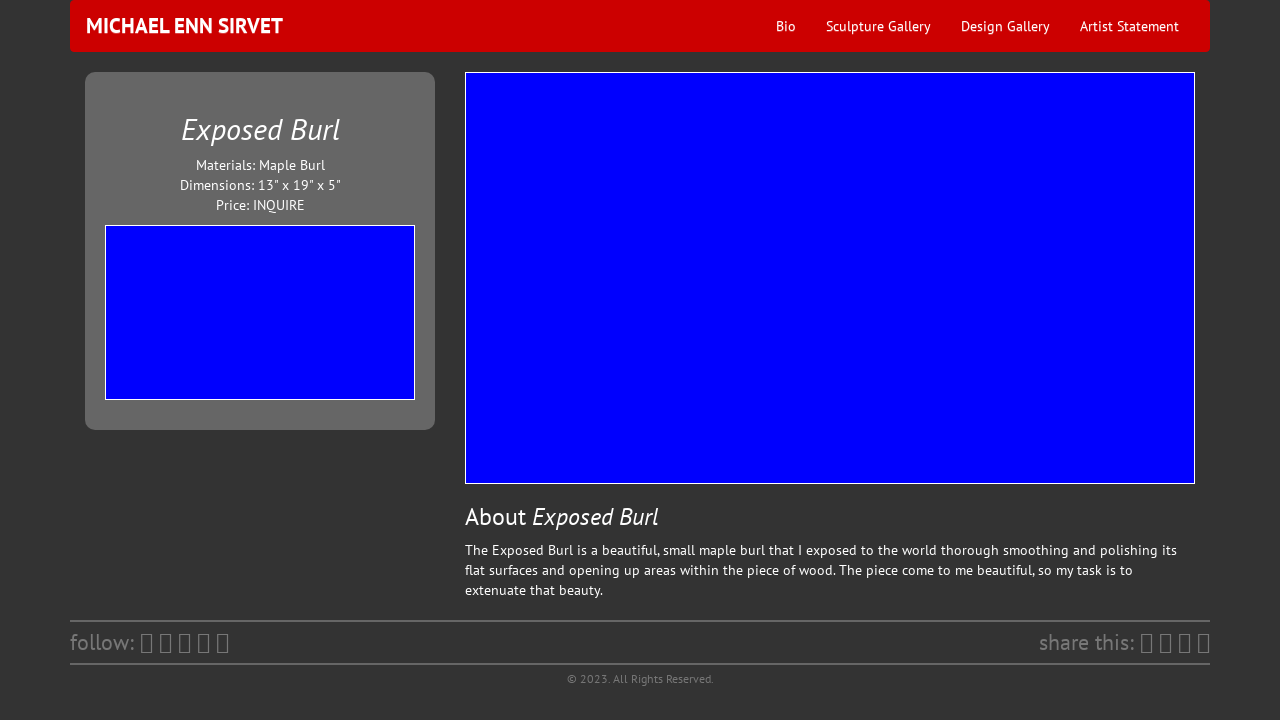What design elements make the 'Exposed Burl' presentation on the website stand out? The presentation of 'Exposed Burl' is visually elegant due to several factors. A minimalist design approach focuses our attention directly on the artwork. The use of a neutral and dark color palette ensures the burl's natural colors are accentuated. The strategic placement of social media sharing icons invites engagement, and the succinct description beneath the image furnishes just enough context without overwhelming the viewer. 